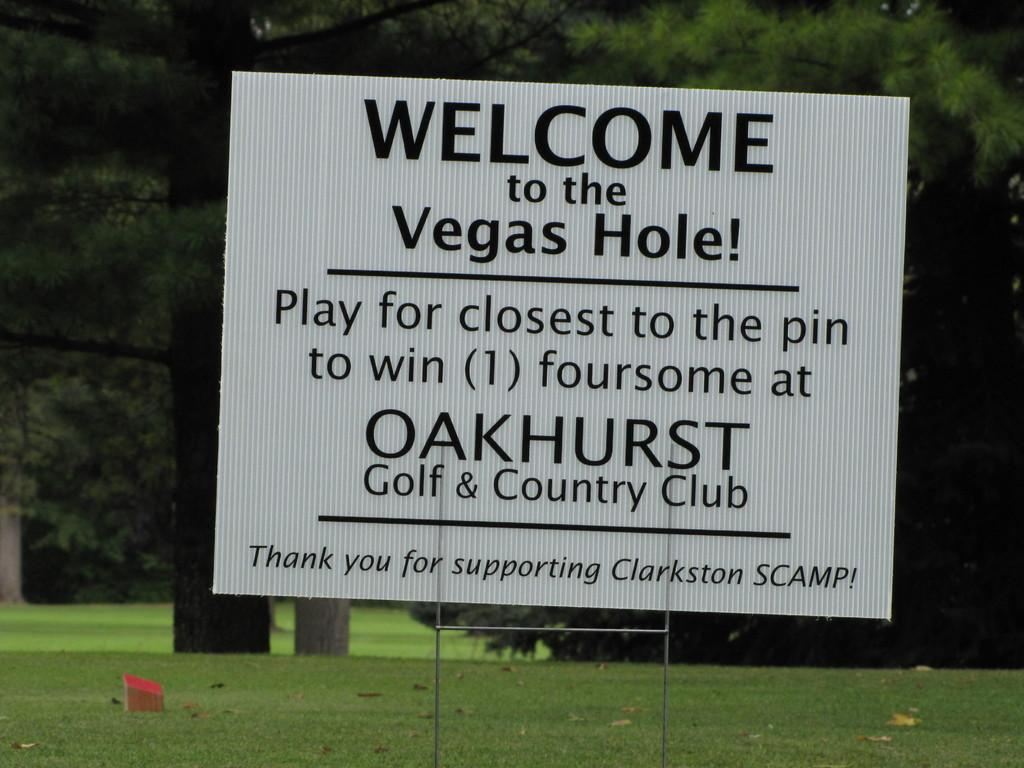What is the main object in the foreground of the image? There is a board with text in the image. How is the board positioned in relation to the other elements in the image? The board is in front of the other elements in the image. What type of surface is visible at the bottom of the image? There is grass at the bottom of the image. What can be seen in the background of the image? There are trees in the background of the image. Is there a spy observing the board in the image? There is no indication of a spy or any person in the image; it only features a board with text, grass, and trees. 